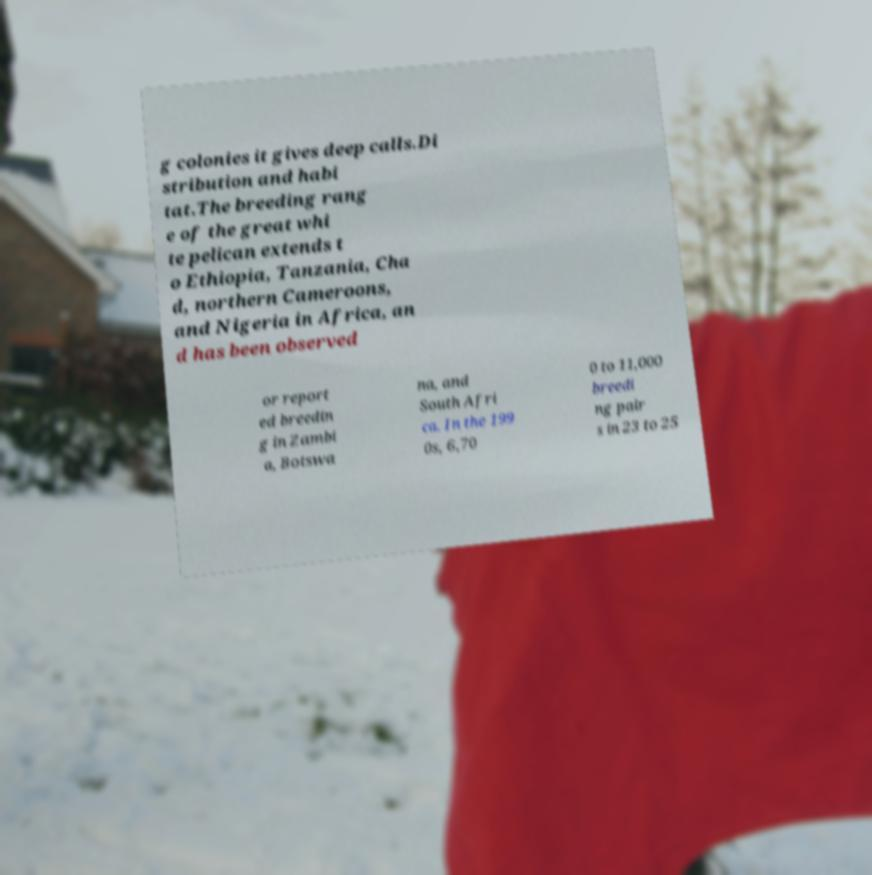What messages or text are displayed in this image? I need them in a readable, typed format. g colonies it gives deep calls.Di stribution and habi tat.The breeding rang e of the great whi te pelican extends t o Ethiopia, Tanzania, Cha d, northern Cameroons, and Nigeria in Africa, an d has been observed or report ed breedin g in Zambi a, Botswa na, and South Afri ca. In the 199 0s, 6,70 0 to 11,000 breedi ng pair s in 23 to 25 